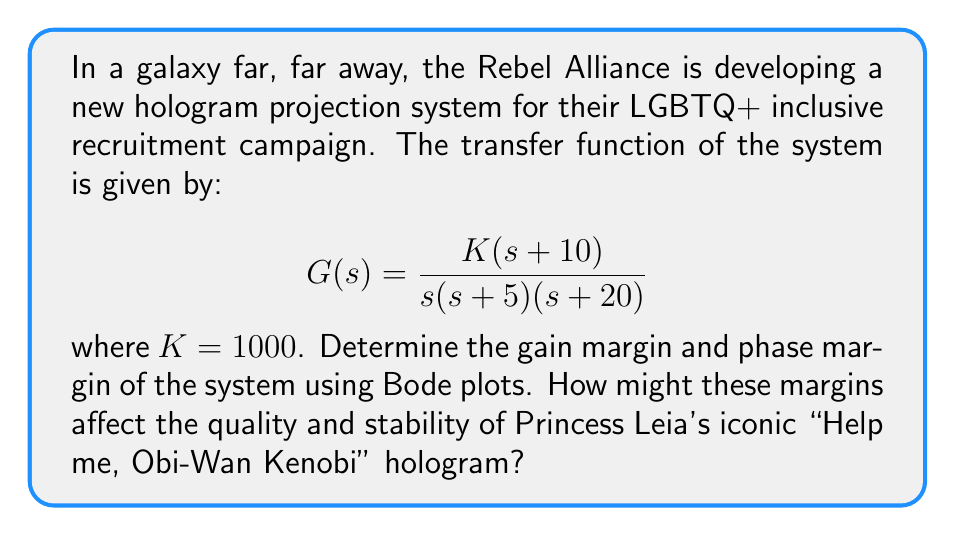Can you answer this question? To analyze the frequency response and determine the gain and phase margins, we'll follow these steps:

1) First, let's break down the transfer function:
   $$G(s) = \frac{1000(s+10)}{s(s+5)(s+20)}$$

2) We need to sketch the Bode magnitude and phase plots. The function has:
   - One zero at $s = -10$
   - Three poles at $s = 0$, $s = -5$, and $s = -20$
   - DC gain of $1000/500 = 2$ or $6$ dB

3) Let's sketch the asymptotic Bode magnitude plot:
   - Start at $6$ dB at $\omega = 0.1$ rad/s
   - -20 dB/decade slope from $\omega = 0.1$ to $\omega = 5$ rad/s
   - -40 dB/decade slope from $\omega = 5$ to $\omega = 10$ rad/s
   - -20 dB/decade slope from $\omega = 10$ to $\omega = 20$ rad/s
   - 0 dB/decade slope after $\omega = 20$ rad/s

4) For the Bode phase plot:
   - Start at -90° at low frequencies due to the pole at origin
   - Additional -45° at $\omega = 5$ rad/s
   - +45° at $\omega = 10$ rad/s (due to the zero)
   - Additional -45° at $\omega = 20$ rad/s

5) The gain margin is determined at the frequency where the phase crosses -180°. This occurs at approximately $\omega = 14$ rad/s. The gain at this frequency is about -3 dB.

   Gain Margin = $0 - (-3) = 3$ dB

6) The phase margin is determined at the gain crossover frequency (where magnitude plot crosses 0 dB). This occurs at approximately $\omega = 11$ rad/s. The phase at this frequency is about -160°.

   Phase Margin = $-160° - (-180°) = 20°$

These margins indicate that the system is stable but with a relatively small margin of stability. For Princess Leia's hologram, this means:

- The gain margin of 3 dB suggests that the hologram's intensity could become unstable if the gain increases by more than 41%.
- The phase margin of 20° indicates that the system might exhibit some oscillatory behavior, potentially causing Leia's image to flicker or distort slightly.
Answer: Gain Margin ≈ 3 dB
Phase Margin ≈ 20° 